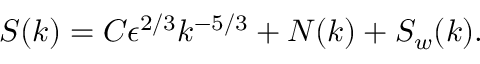<formula> <loc_0><loc_0><loc_500><loc_500>S ( k ) = C \epsilon ^ { 2 / 3 } k ^ { - 5 / 3 } + N ( k ) + S _ { w } ( k ) .</formula> 